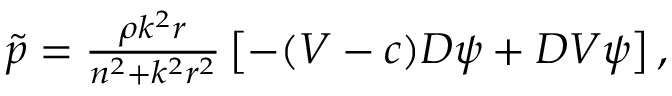Convert formula to latex. <formula><loc_0><loc_0><loc_500><loc_500>\begin{array} { r } { \tilde { p } = \frac { \rho k ^ { 2 } r } { n ^ { 2 } + k ^ { 2 } r ^ { 2 } } \left [ - ( V - c ) D \psi + D V \psi \right ] , } \end{array}</formula> 